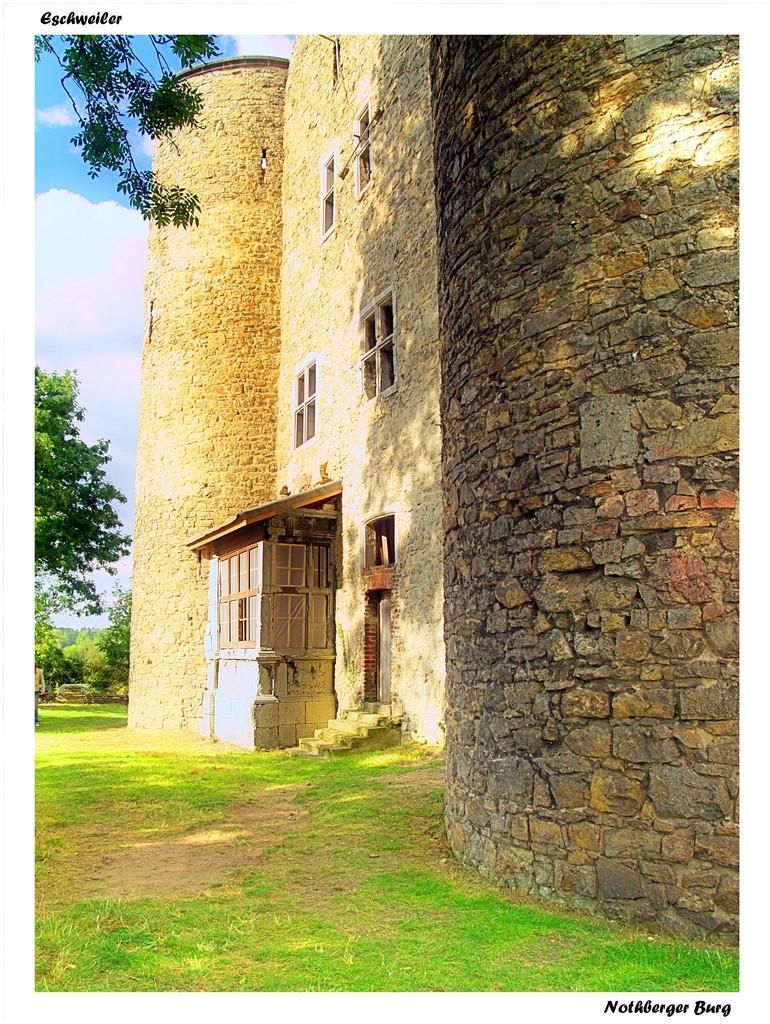How would you summarize this image in a sentence or two? In this image in the right there is a building. In the background there are trees. The sky is cloudy. There are windows and door on the wall. 